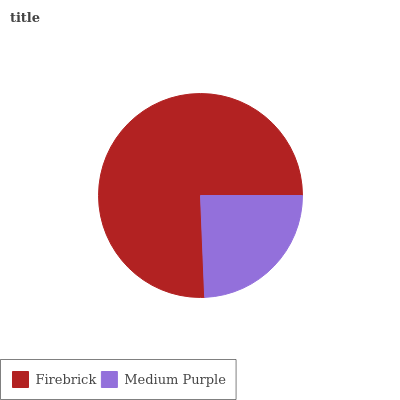Is Medium Purple the minimum?
Answer yes or no. Yes. Is Firebrick the maximum?
Answer yes or no. Yes. Is Medium Purple the maximum?
Answer yes or no. No. Is Firebrick greater than Medium Purple?
Answer yes or no. Yes. Is Medium Purple less than Firebrick?
Answer yes or no. Yes. Is Medium Purple greater than Firebrick?
Answer yes or no. No. Is Firebrick less than Medium Purple?
Answer yes or no. No. Is Firebrick the high median?
Answer yes or no. Yes. Is Medium Purple the low median?
Answer yes or no. Yes. Is Medium Purple the high median?
Answer yes or no. No. Is Firebrick the low median?
Answer yes or no. No. 